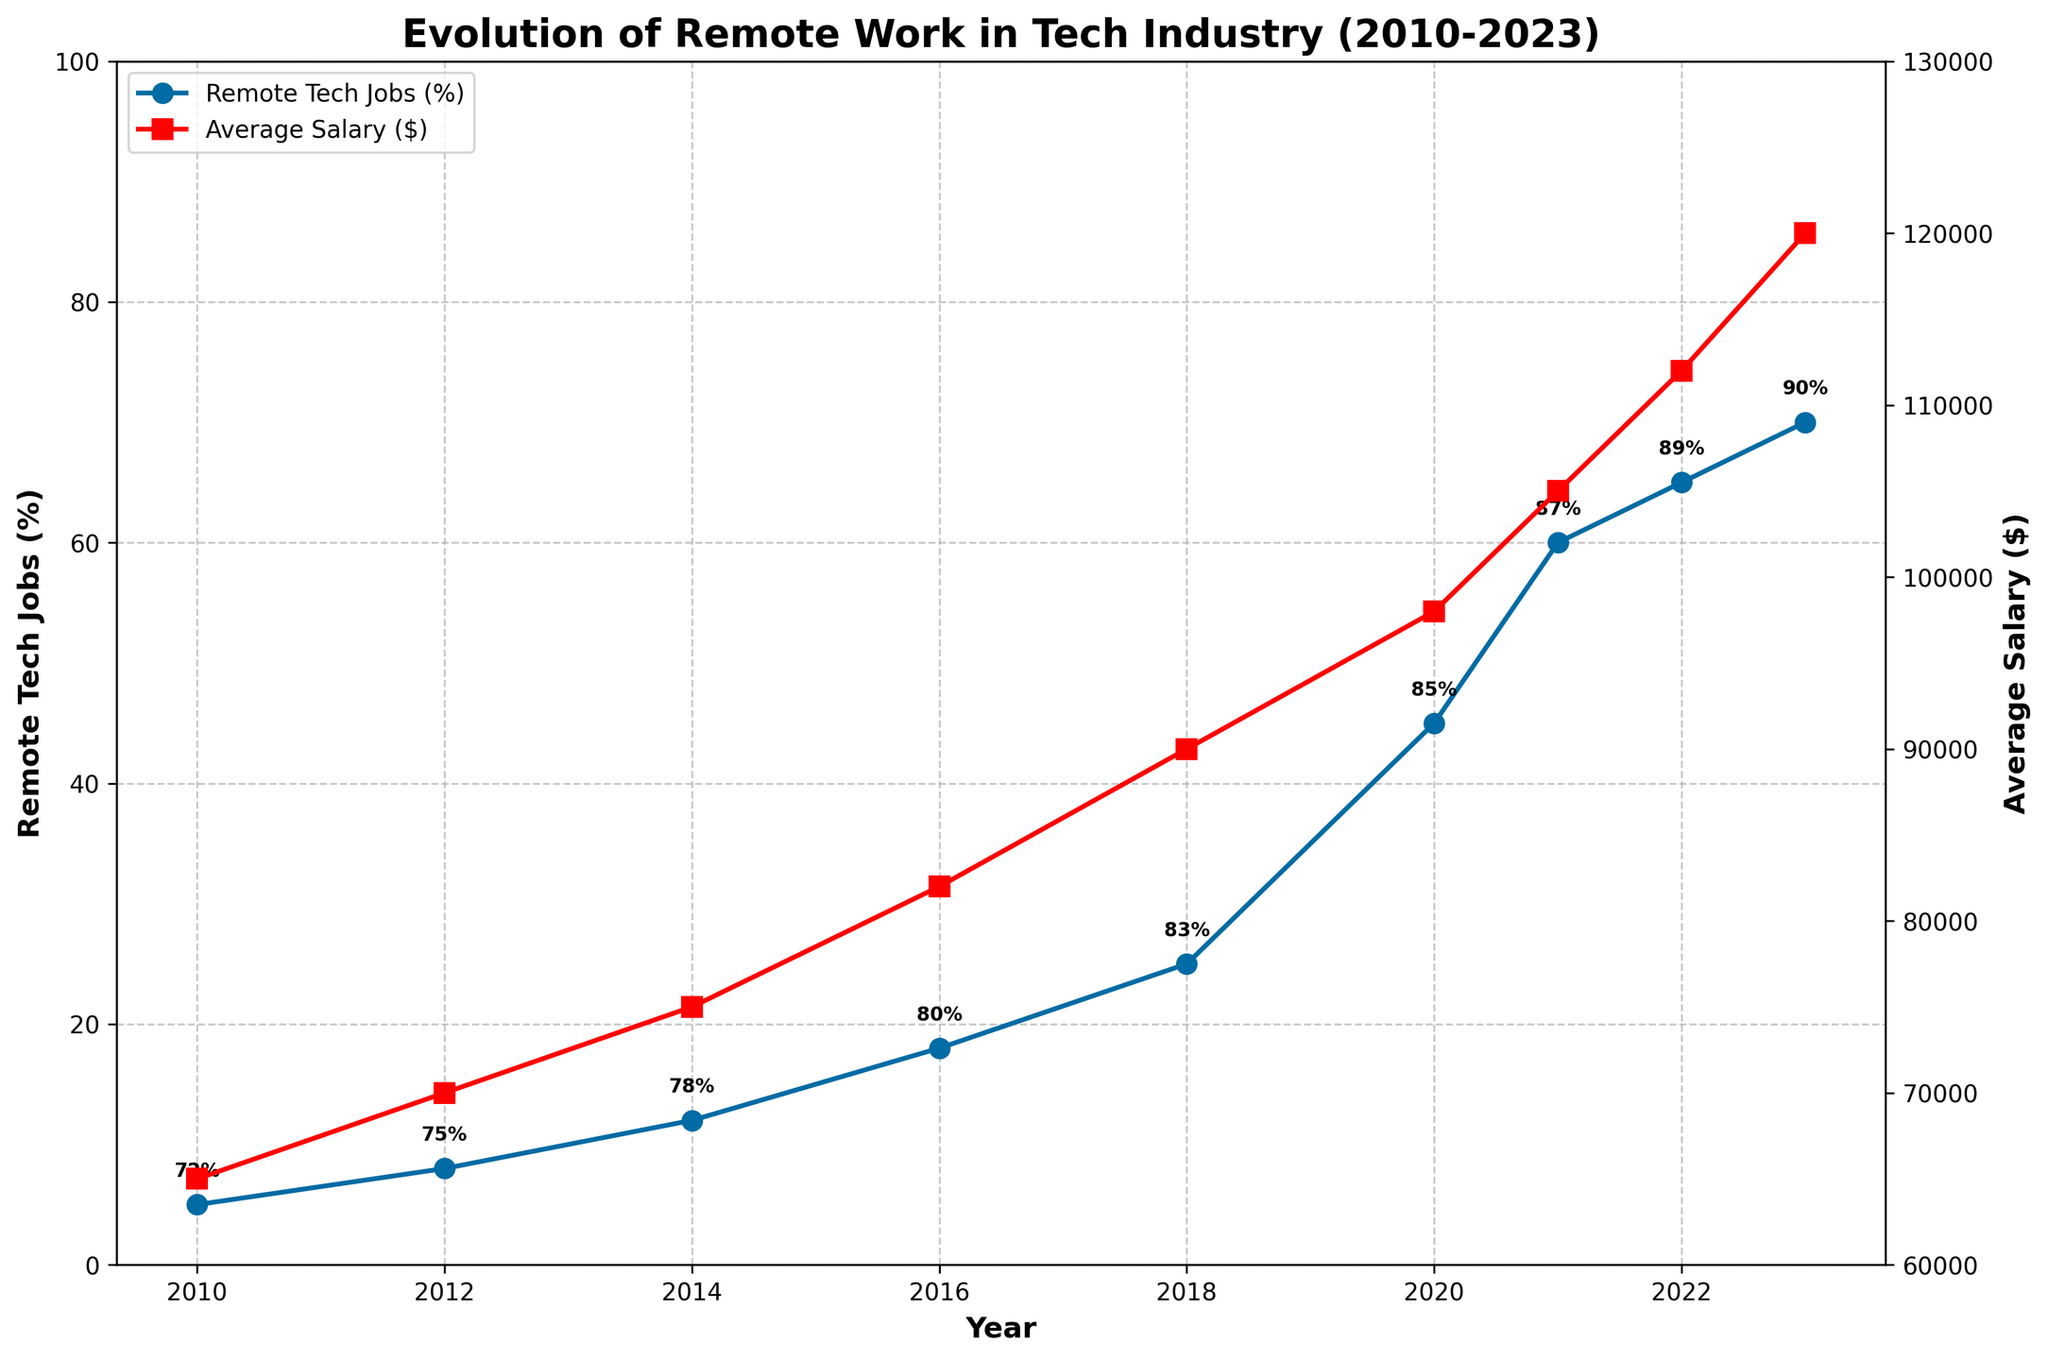What was the percentage increase in remote tech jobs from 2010 to 2023? To find the percentage increase in remote tech jobs from 2010 to 2023, subtract the 2010 value (5%) from the 2023 value (70%), then divide the result by the 2010 value and multiply by 100: ((70 - 5) / 5) * 100.
Answer: 1300% By how much did the average salary for remote tech jobs increase between 2012 and 2021? Subtract the average salary in 2012 ($70,000) from the average salary in 2021 ($105,000): $105,000 - $70,000.
Answer: $35,000 Which year had the greatest increase in the percentage of remote tech jobs compared to the previous year? Compare the percentage increases between each consecutive year pair. The largest increase occurs between 2018 (25%) and 2020 (45%), a difference of 20%.
Answer: 2020 How does remote work satisfaction in 2023 compare to that in 2010? Subtract the remote work satisfaction percentage in 2010 (72%) from the percentage in 2023 (90%): 90% - 72%.
Answer: 18% higher Which company is listed as the top remote tech company in 2016? Look at the data row for 2016 and check the column for "Top Remote Tech Companies": 2016 lists Apple as the top remote tech company.
Answer: Apple By how much did the average salary increase from 2010 to 2018? Subtract the average salary in 2010 ($65,000) from the average salary in 2018 ($90,000): $90,000 - $65,000.
Answer: $25,000 Between which years was the percentage of remote tech jobs doubled? Identify the years where the percentage of remote tech jobs was roughly half the value of the following year. The percentage of remote tech jobs doubled from 2012 (8%) to 2016 (18%).
Answer: 2012 to 2016 Which year had the smallest increase in remote work satisfaction, and what was the increase? Compare the increases in remote work satisfaction between each consecutive year pair. The smallest increase is between 2012 (75%) and 2014 (78%), an increase of 3%.
Answer: 2014 (3%) What is the trend in average salary for remote tech jobs from 2010 to 2023? The average salary for remote tech jobs shows a consistent upward trend from 2010 ($65,000) to 2023 ($120,000), continuously increasing over the years.
Answer: Upward trend 